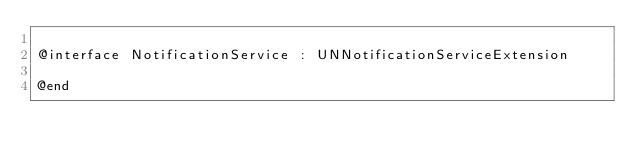<code> <loc_0><loc_0><loc_500><loc_500><_C_>
@interface NotificationService : UNNotificationServiceExtension

@end
</code> 